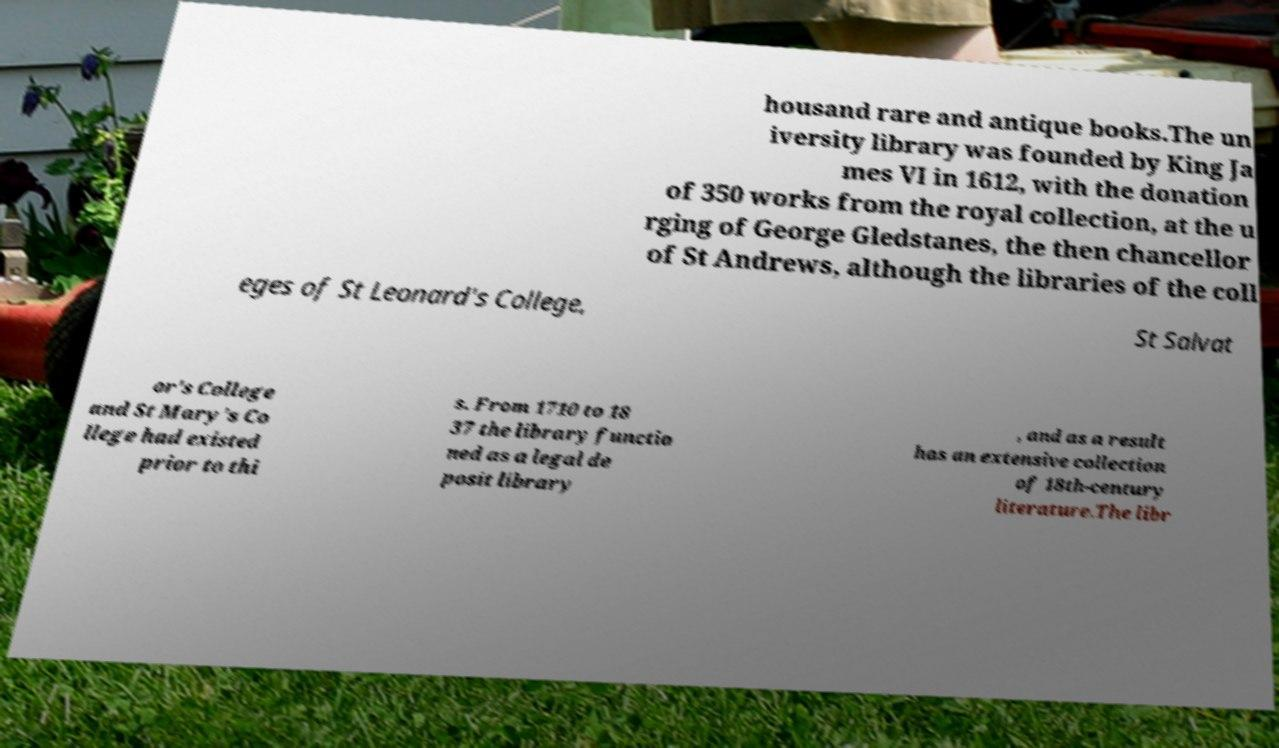Can you read and provide the text displayed in the image?This photo seems to have some interesting text. Can you extract and type it out for me? housand rare and antique books.The un iversity library was founded by King Ja mes VI in 1612, with the donation of 350 works from the royal collection, at the u rging of George Gledstanes, the then chancellor of St Andrews, although the libraries of the coll eges of St Leonard's College, St Salvat or's College and St Mary's Co llege had existed prior to thi s. From 1710 to 18 37 the library functio ned as a legal de posit library , and as a result has an extensive collection of 18th-century literature.The libr 